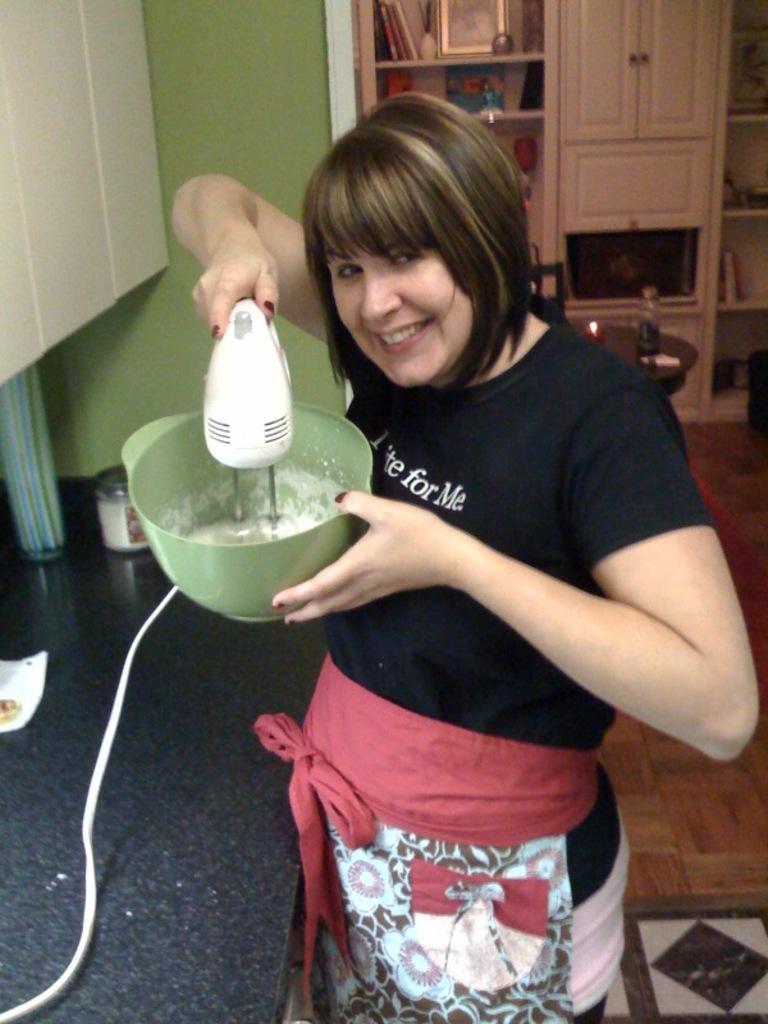How would you summarize this image in a sentence or two? In the center of the image, we can see a lady holding a blender machine and in the background, there are cupboards, frames and a bottle and a light on the table and we can see some other objects on the counter table. At the bottom, there is floor. 